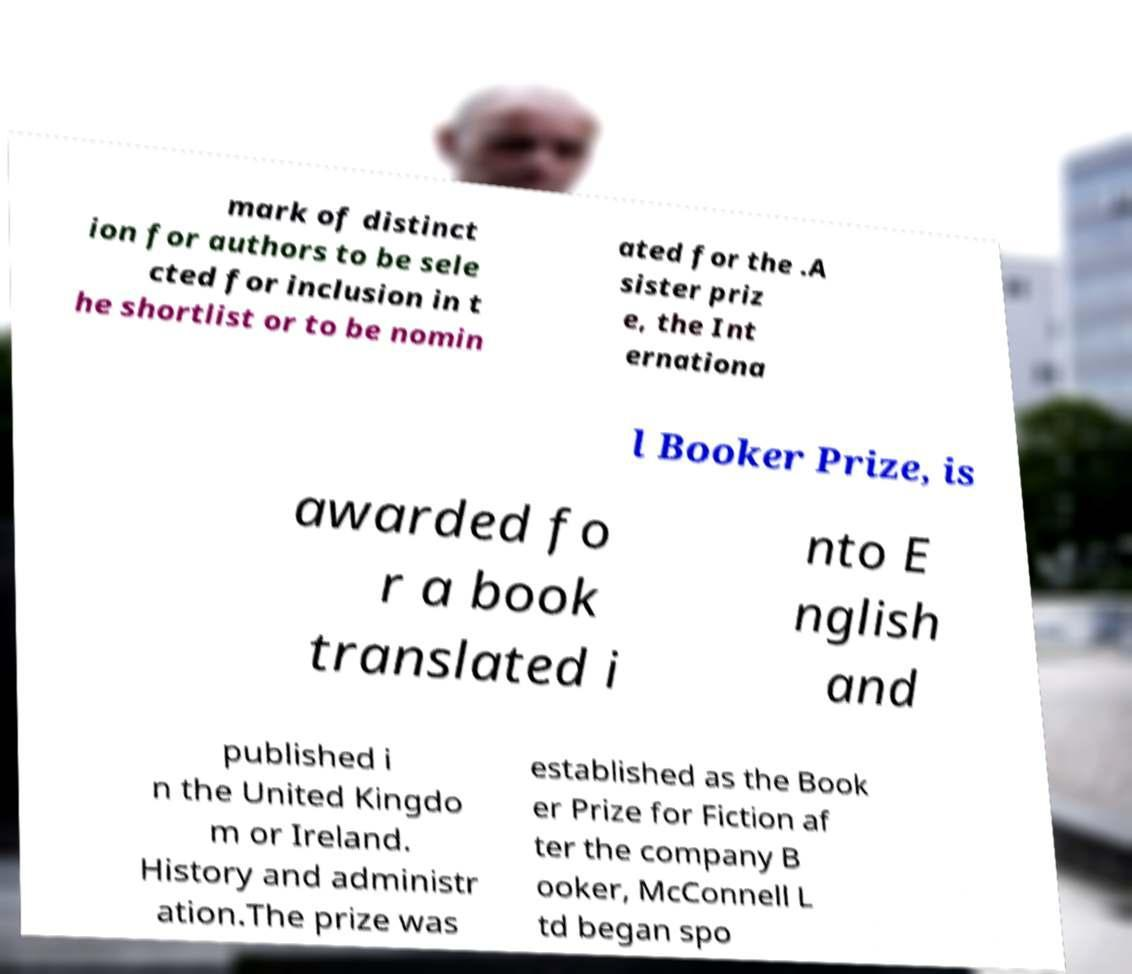Please identify and transcribe the text found in this image. mark of distinct ion for authors to be sele cted for inclusion in t he shortlist or to be nomin ated for the .A sister priz e, the Int ernationa l Booker Prize, is awarded fo r a book translated i nto E nglish and published i n the United Kingdo m or Ireland. History and administr ation.The prize was established as the Book er Prize for Fiction af ter the company B ooker, McConnell L td began spo 